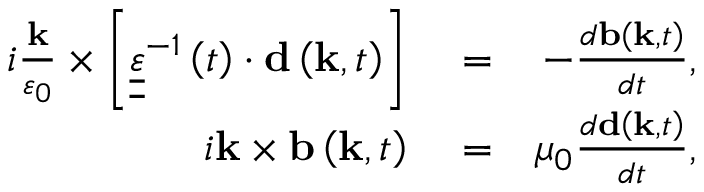Convert formula to latex. <formula><loc_0><loc_0><loc_500><loc_500>\begin{array} { r l r } { i \frac { k } { \varepsilon _ { 0 } } \times \left [ { \underline { { \underline { \varepsilon } } } } ^ { - 1 } \left ( t \right ) \cdot { d } \left ( { k } , t \right ) \right ] } & = } & { - \frac { d { b } \left ( { k } , t \right ) } { d t } , } \\ { i { k } \times { b } \left ( { k } , t \right ) } & = } & { \mu _ { 0 } \frac { d { d } \left ( { k } , t \right ) } { d t } , } \end{array}</formula> 